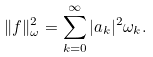<formula> <loc_0><loc_0><loc_500><loc_500>\| f \| ^ { 2 } _ { \omega } = \sum _ { k = 0 } ^ { \infty } | a _ { k } | ^ { 2 } \omega _ { k } .</formula> 